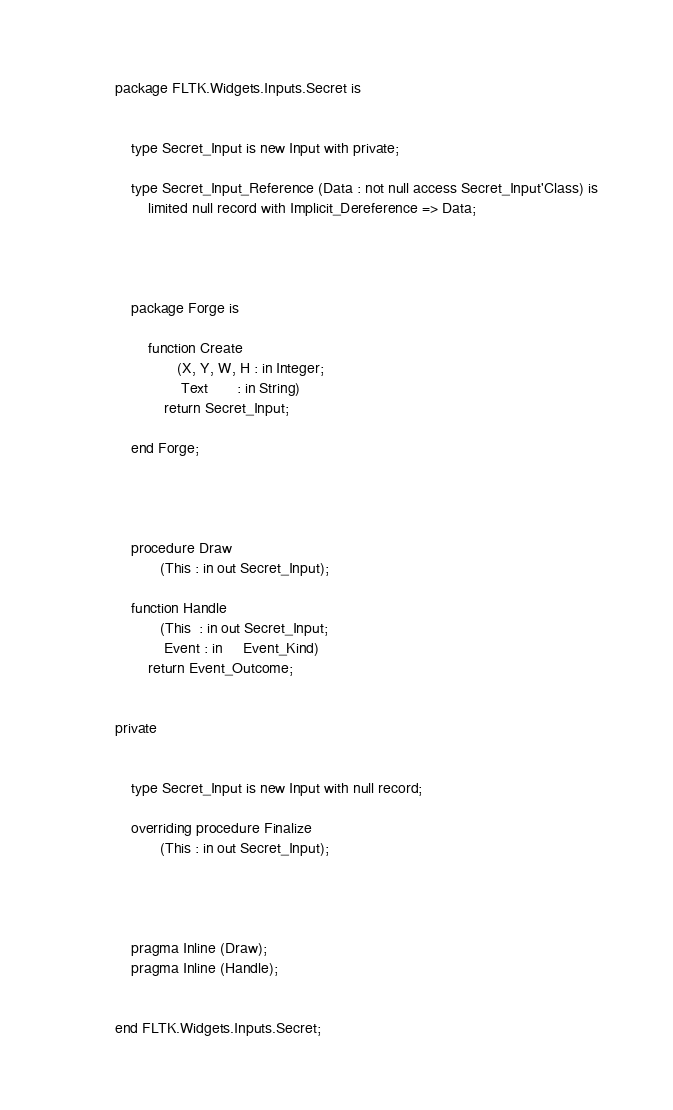<code> <loc_0><loc_0><loc_500><loc_500><_Ada_>

package FLTK.Widgets.Inputs.Secret is


    type Secret_Input is new Input with private;

    type Secret_Input_Reference (Data : not null access Secret_Input'Class) is
        limited null record with Implicit_Dereference => Data;




    package Forge is

        function Create
               (X, Y, W, H : in Integer;
                Text       : in String)
            return Secret_Input;

    end Forge;




    procedure Draw
           (This : in out Secret_Input);

    function Handle
           (This  : in out Secret_Input;
            Event : in     Event_Kind)
        return Event_Outcome;


private


    type Secret_Input is new Input with null record;

    overriding procedure Finalize
           (This : in out Secret_Input);




    pragma Inline (Draw);
    pragma Inline (Handle);


end FLTK.Widgets.Inputs.Secret;

</code> 